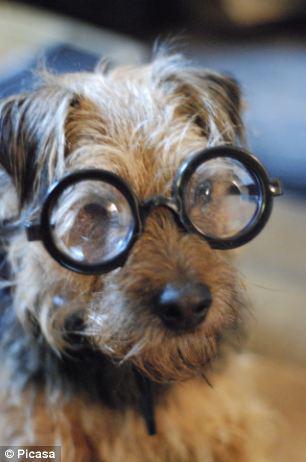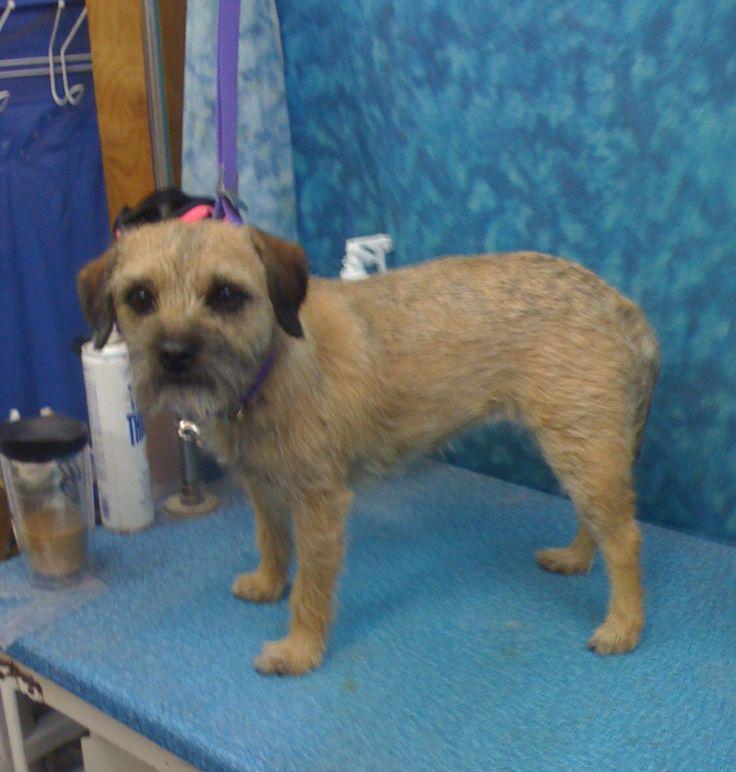The first image is the image on the left, the second image is the image on the right. For the images displayed, is the sentence "There is a single dog with it's tongue slightly visible in the right image." factually correct? Answer yes or no. No. The first image is the image on the left, the second image is the image on the right. Given the left and right images, does the statement "There is a Border Terrier standing inside in the right image." hold true? Answer yes or no. Yes. 